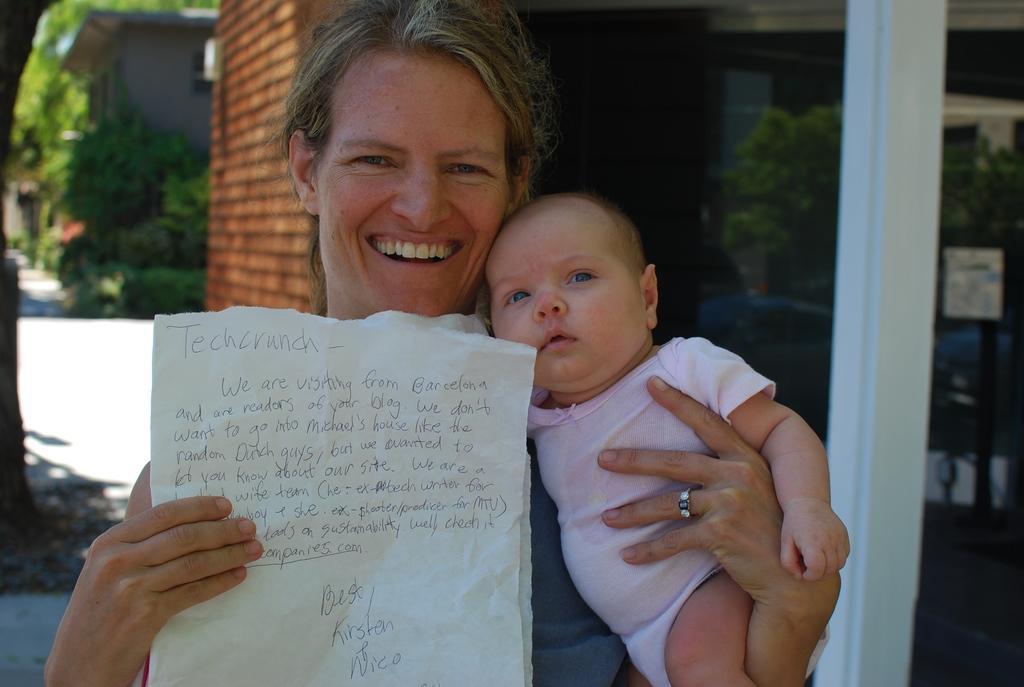Describe this image in one or two sentences. In this image we can see two persons. A lady is carrying a baby and holding some paper. There are few houses in the image. There are many trees and plants in the image. There is some reflection on the glass. 